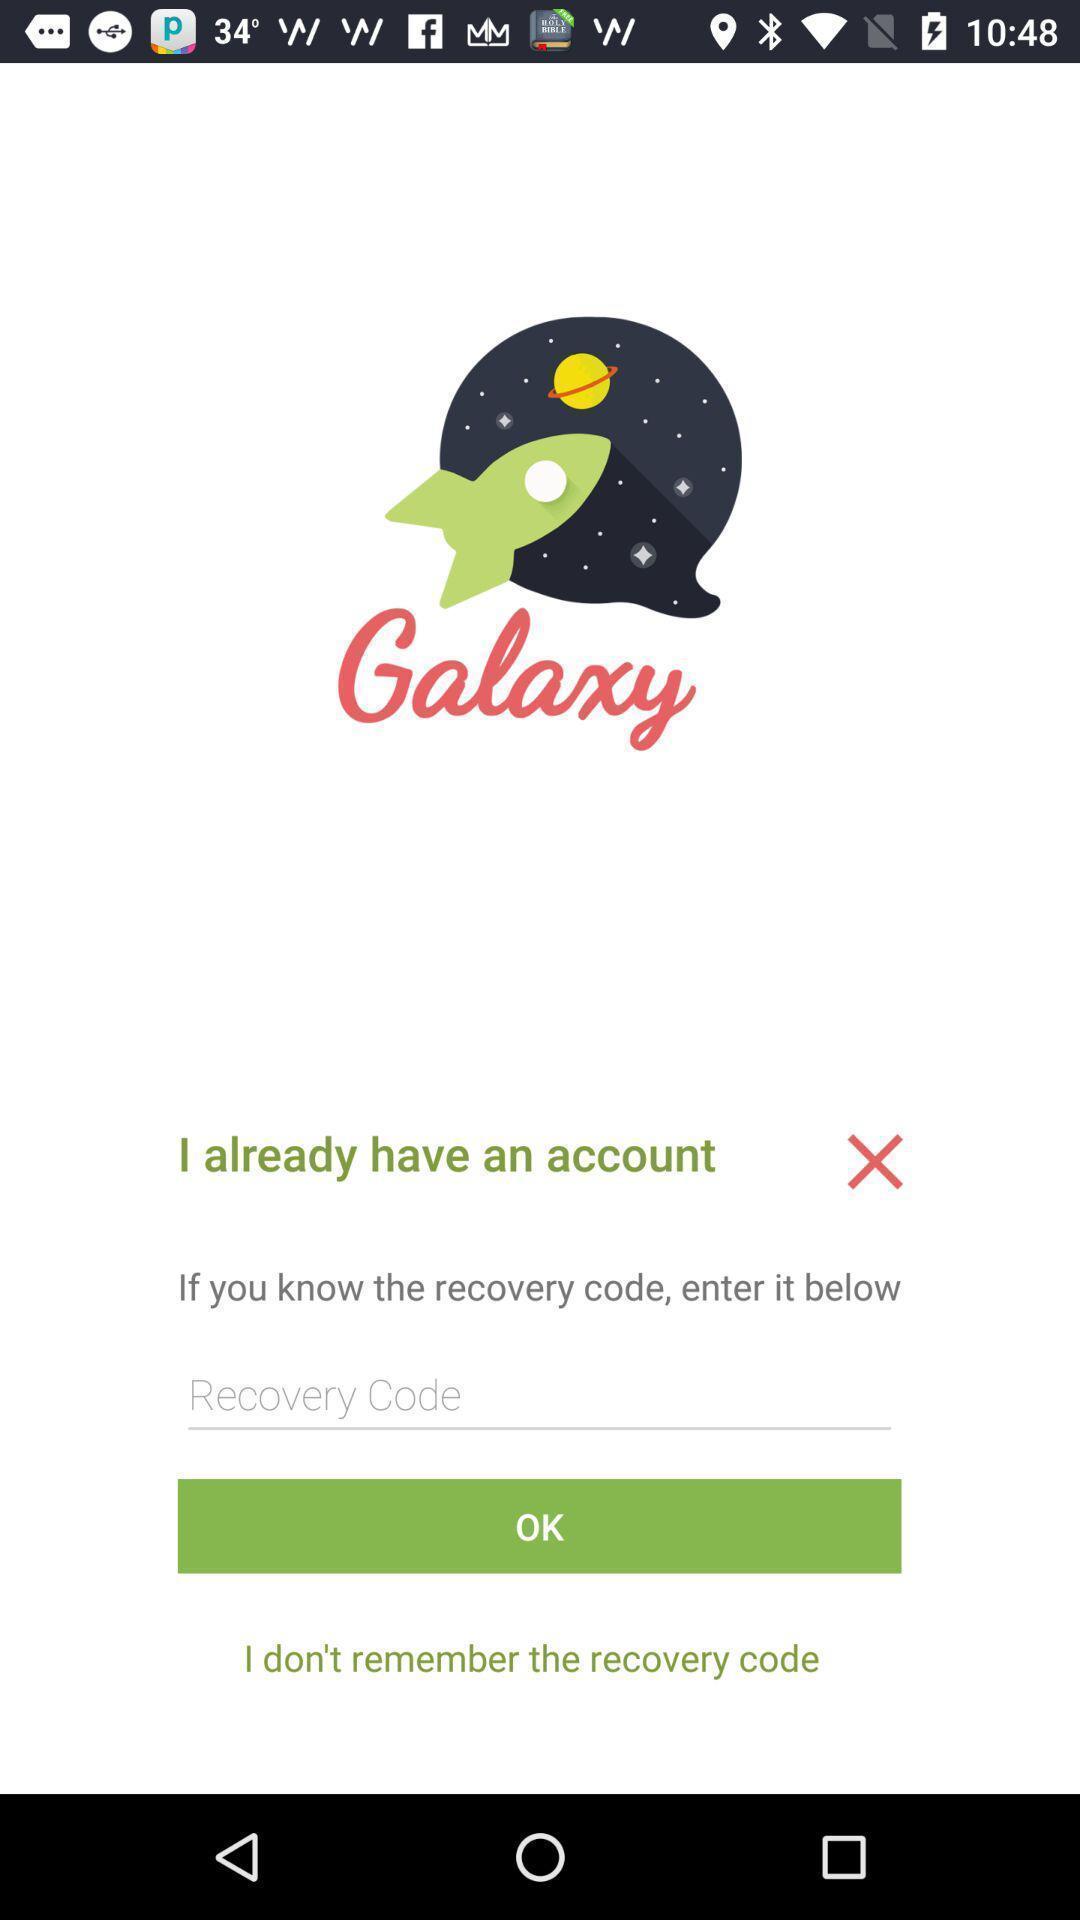What is the overall content of this screenshot? Page showing login page. 